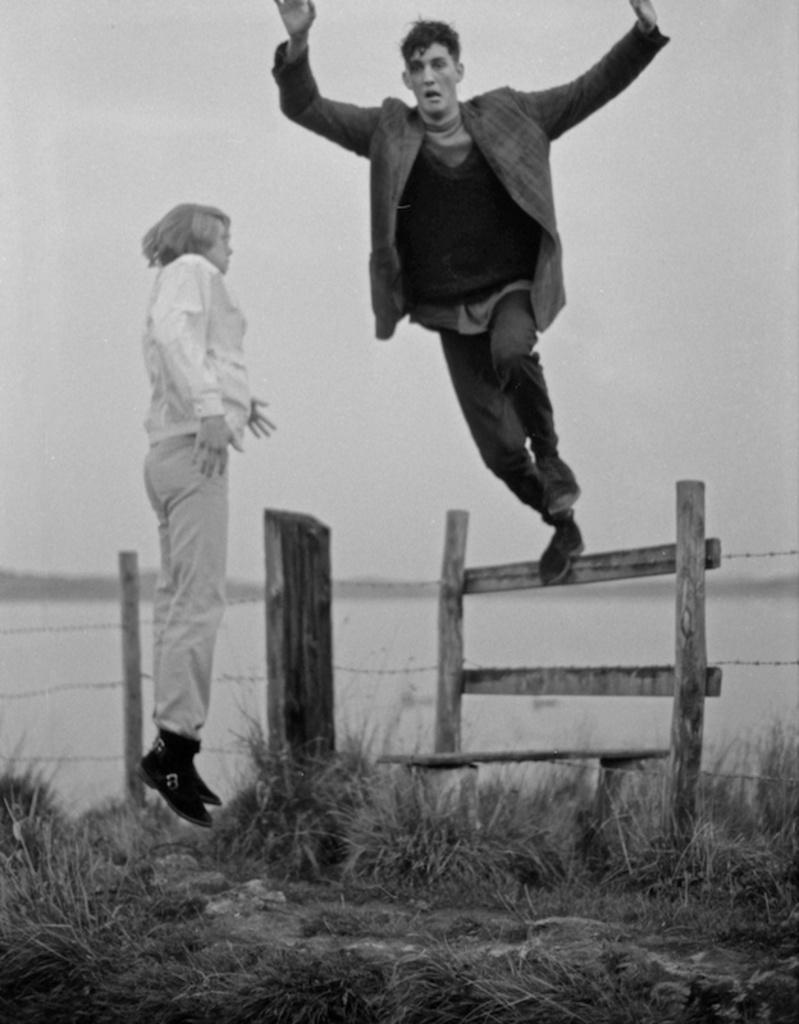Describe this image in one or two sentences. There is a person in white color jumping on the ground, on which, there is grass. On the right side, there is a person jumping from the wooden fencing. In the background, there is water, there is a mountain and there is sky. 